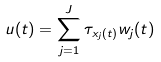Convert formula to latex. <formula><loc_0><loc_0><loc_500><loc_500>u ( t ) = \sum _ { j = 1 } ^ { J } \tau _ { x _ { j } ( t ) } w _ { j } ( t )</formula> 